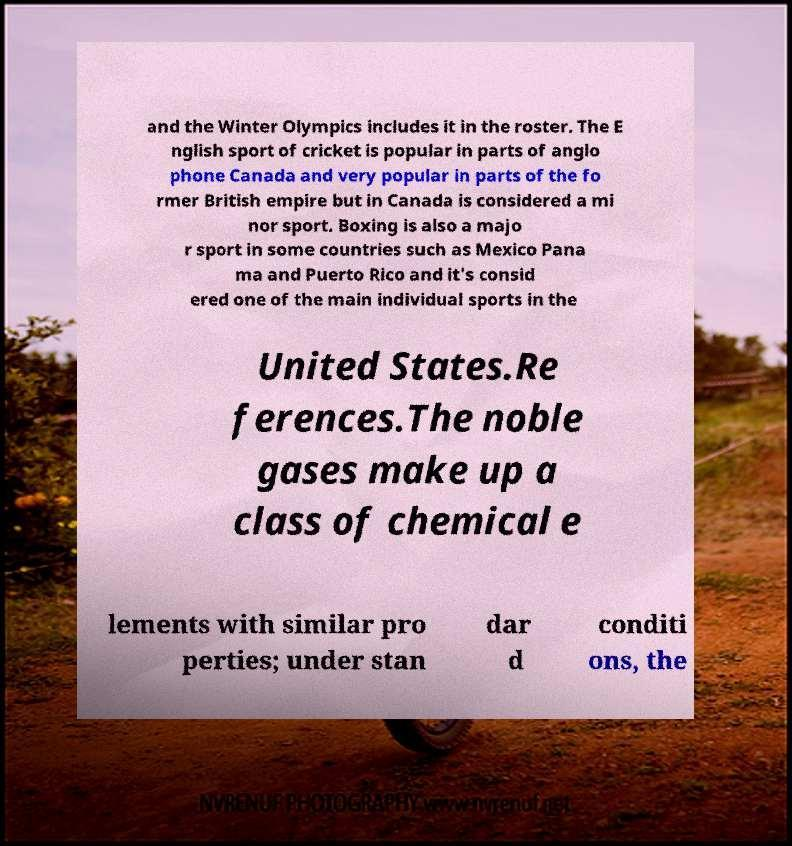I need the written content from this picture converted into text. Can you do that? and the Winter Olympics includes it in the roster. The E nglish sport of cricket is popular in parts of anglo phone Canada and very popular in parts of the fo rmer British empire but in Canada is considered a mi nor sport. Boxing is also a majo r sport in some countries such as Mexico Pana ma and Puerto Rico and it's consid ered one of the main individual sports in the United States.Re ferences.The noble gases make up a class of chemical e lements with similar pro perties; under stan dar d conditi ons, the 